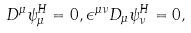Convert formula to latex. <formula><loc_0><loc_0><loc_500><loc_500>D ^ { \mu } \psi ^ { H } _ { \mu } = 0 , \epsilon ^ { \mu \nu } D _ { \mu } \psi ^ { H } _ { \nu } = 0 ,</formula> 